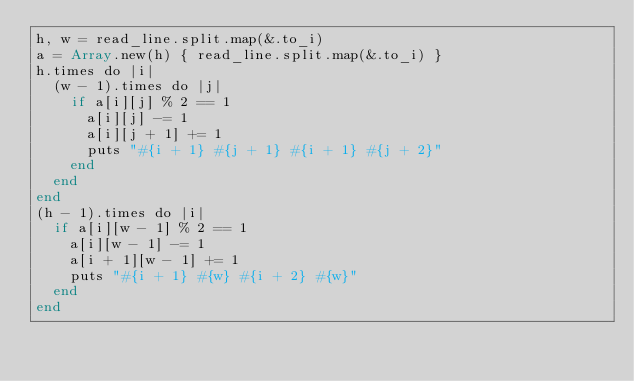<code> <loc_0><loc_0><loc_500><loc_500><_Crystal_>h, w = read_line.split.map(&.to_i)
a = Array.new(h) { read_line.split.map(&.to_i) }
h.times do |i|
  (w - 1).times do |j|
    if a[i][j] % 2 == 1
      a[i][j] -= 1
      a[i][j + 1] += 1
      puts "#{i + 1} #{j + 1} #{i + 1} #{j + 2}"
    end
  end
end
(h - 1).times do |i|
  if a[i][w - 1] % 2 == 1
    a[i][w - 1] -= 1
    a[i + 1][w - 1] += 1
    puts "#{i + 1} #{w} #{i + 2} #{w}"
  end
end
</code> 